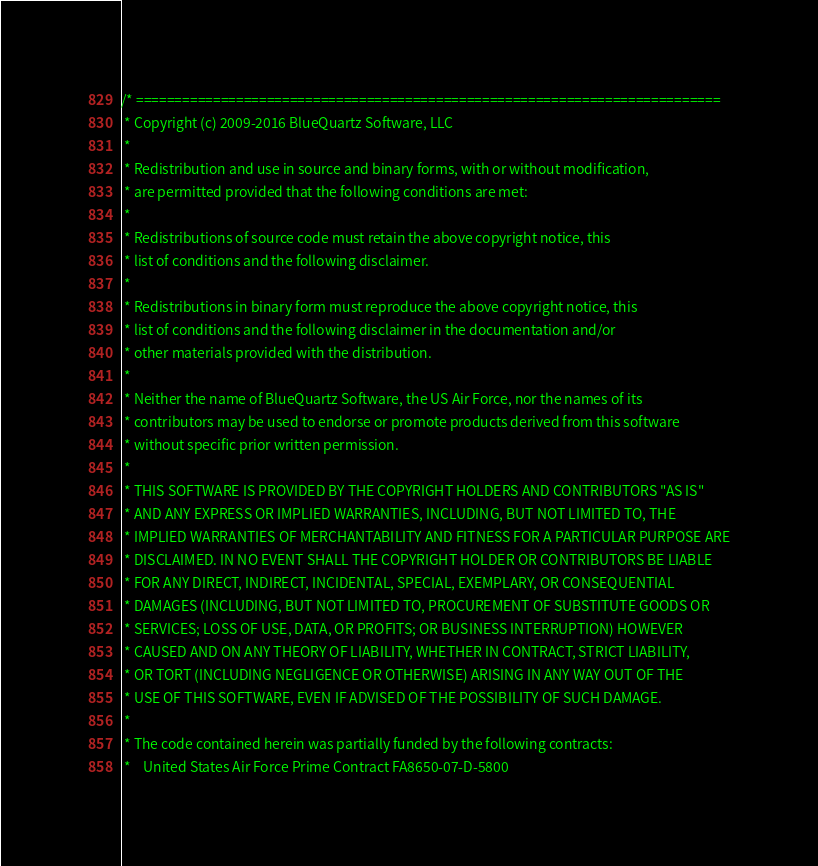Convert code to text. <code><loc_0><loc_0><loc_500><loc_500><_C++_>/* ============================================================================
 * Copyright (c) 2009-2016 BlueQuartz Software, LLC
 *
 * Redistribution and use in source and binary forms, with or without modification,
 * are permitted provided that the following conditions are met:
 *
 * Redistributions of source code must retain the above copyright notice, this
 * list of conditions and the following disclaimer.
 *
 * Redistributions in binary form must reproduce the above copyright notice, this
 * list of conditions and the following disclaimer in the documentation and/or
 * other materials provided with the distribution.
 *
 * Neither the name of BlueQuartz Software, the US Air Force, nor the names of its
 * contributors may be used to endorse or promote products derived from this software
 * without specific prior written permission.
 *
 * THIS SOFTWARE IS PROVIDED BY THE COPYRIGHT HOLDERS AND CONTRIBUTORS "AS IS"
 * AND ANY EXPRESS OR IMPLIED WARRANTIES, INCLUDING, BUT NOT LIMITED TO, THE
 * IMPLIED WARRANTIES OF MERCHANTABILITY AND FITNESS FOR A PARTICULAR PURPOSE ARE
 * DISCLAIMED. IN NO EVENT SHALL THE COPYRIGHT HOLDER OR CONTRIBUTORS BE LIABLE
 * FOR ANY DIRECT, INDIRECT, INCIDENTAL, SPECIAL, EXEMPLARY, OR CONSEQUENTIAL
 * DAMAGES (INCLUDING, BUT NOT LIMITED TO, PROCUREMENT OF SUBSTITUTE GOODS OR
 * SERVICES; LOSS OF USE, DATA, OR PROFITS; OR BUSINESS INTERRUPTION) HOWEVER
 * CAUSED AND ON ANY THEORY OF LIABILITY, WHETHER IN CONTRACT, STRICT LIABILITY,
 * OR TORT (INCLUDING NEGLIGENCE OR OTHERWISE) ARISING IN ANY WAY OUT OF THE
 * USE OF THIS SOFTWARE, EVEN IF ADVISED OF THE POSSIBILITY OF SUCH DAMAGE.
 *
 * The code contained herein was partially funded by the following contracts:
 *    United States Air Force Prime Contract FA8650-07-D-5800</code> 